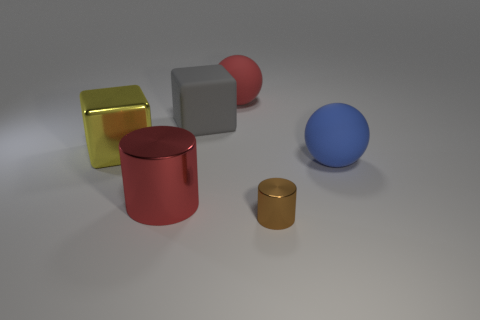Add 4 purple balls. How many objects exist? 10 Subtract all cubes. How many objects are left? 4 Add 4 small metallic objects. How many small metallic objects exist? 5 Subtract 0 gray cylinders. How many objects are left? 6 Subtract all red spheres. Subtract all small purple matte spheres. How many objects are left? 5 Add 1 big yellow things. How many big yellow things are left? 2 